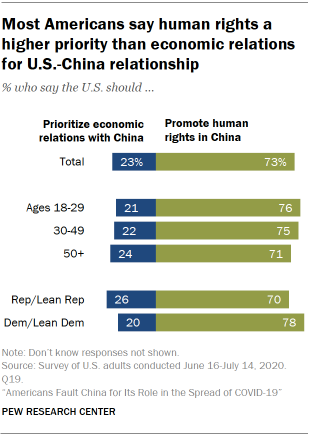Highlight a few significant elements in this photo. The sum of the two largest values in the green bar is greater than 100. The value of the blue bar for the 50+ age group is 24. 